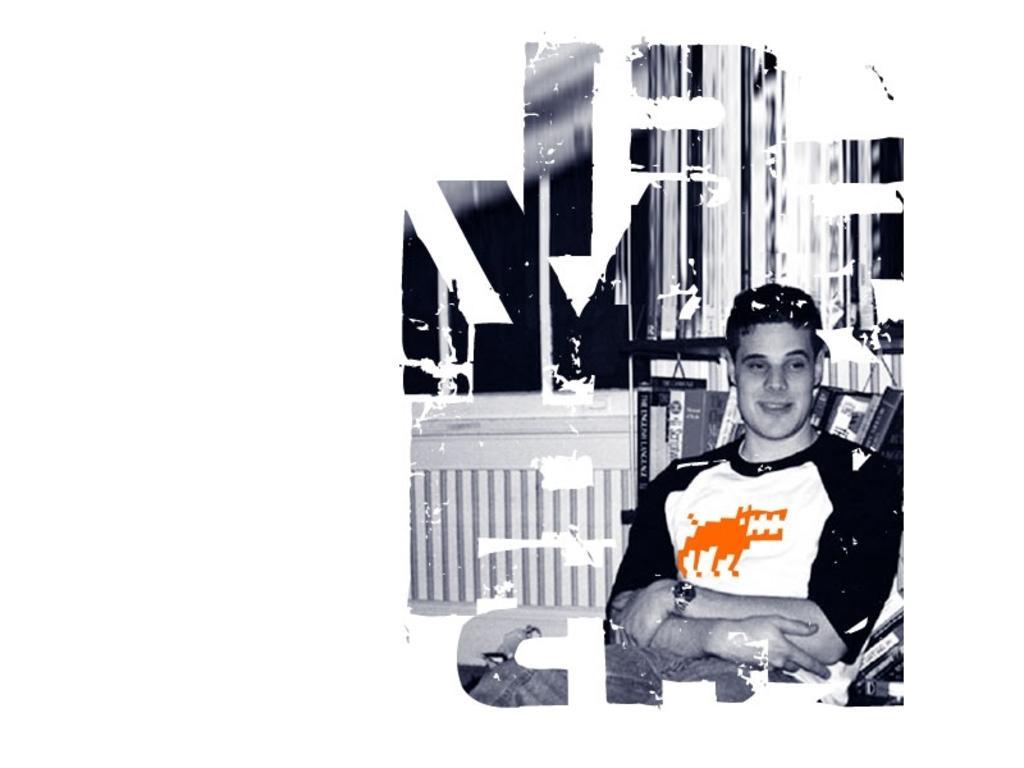Can you describe this image briefly? This is an edited picture, in this picture we can see text. On the right there is a person sitting in chair. In the background there is a window. In the center there are books in the rack. 